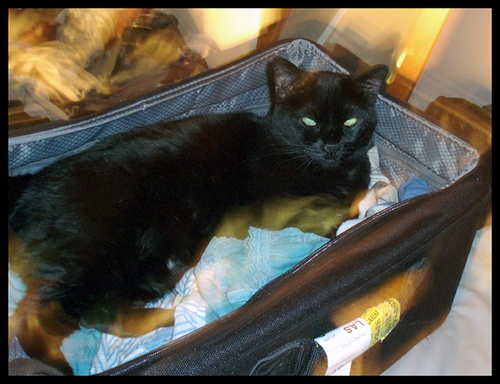Describe the objects in this image and their specific colors. I can see suitcase in black, gray, maroon, and olive tones and cat in black, olive, maroon, and gray tones in this image. 